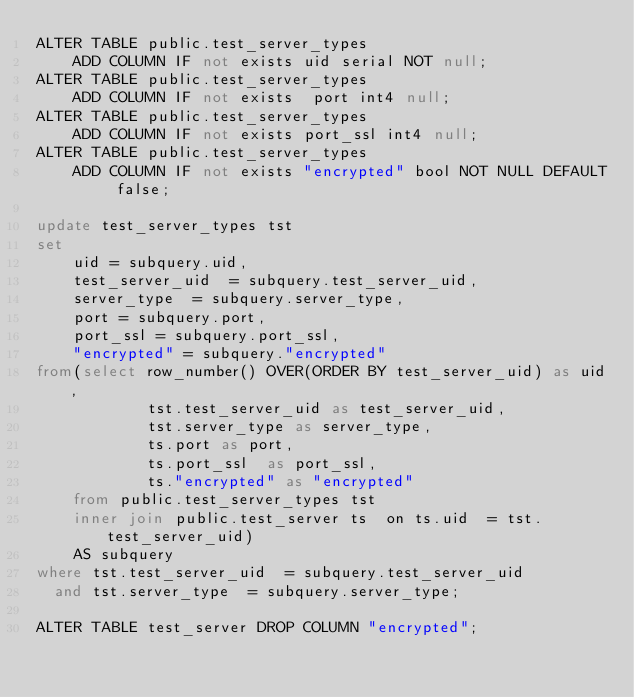Convert code to text. <code><loc_0><loc_0><loc_500><loc_500><_SQL_>ALTER TABLE public.test_server_types
    ADD COLUMN IF not exists uid serial NOT null;
ALTER TABLE public.test_server_types
    ADD COLUMN IF not exists  port int4 null;
ALTER TABLE public.test_server_types
    ADD COLUMN IF not exists port_ssl int4 null;
ALTER TABLE public.test_server_types
    ADD COLUMN IF not exists "encrypted" bool NOT NULL DEFAULT false;

update test_server_types tst
set
    uid = subquery.uid,
    test_server_uid  = subquery.test_server_uid,
    server_type  = subquery.server_type,
    port = subquery.port,
    port_ssl = subquery.port_ssl,
    "encrypted" = subquery."encrypted"
from(select row_number() OVER(ORDER BY test_server_uid) as uid,
            tst.test_server_uid as test_server_uid,
            tst.server_type as server_type,
            ts.port as port,
            ts.port_ssl  as port_ssl,
            ts."encrypted" as "encrypted"
    from public.test_server_types tst
    inner join public.test_server ts  on ts.uid  = tst.test_server_uid)
    AS subquery
where tst.test_server_uid  = subquery.test_server_uid
  and tst.server_type  = subquery.server_type;

ALTER TABLE test_server DROP COLUMN "encrypted";</code> 